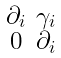<formula> <loc_0><loc_0><loc_500><loc_500>\begin{smallmatrix} \partial _ { i } & \gamma _ { i } \\ 0 & \partial _ { i } \end{smallmatrix}</formula> 